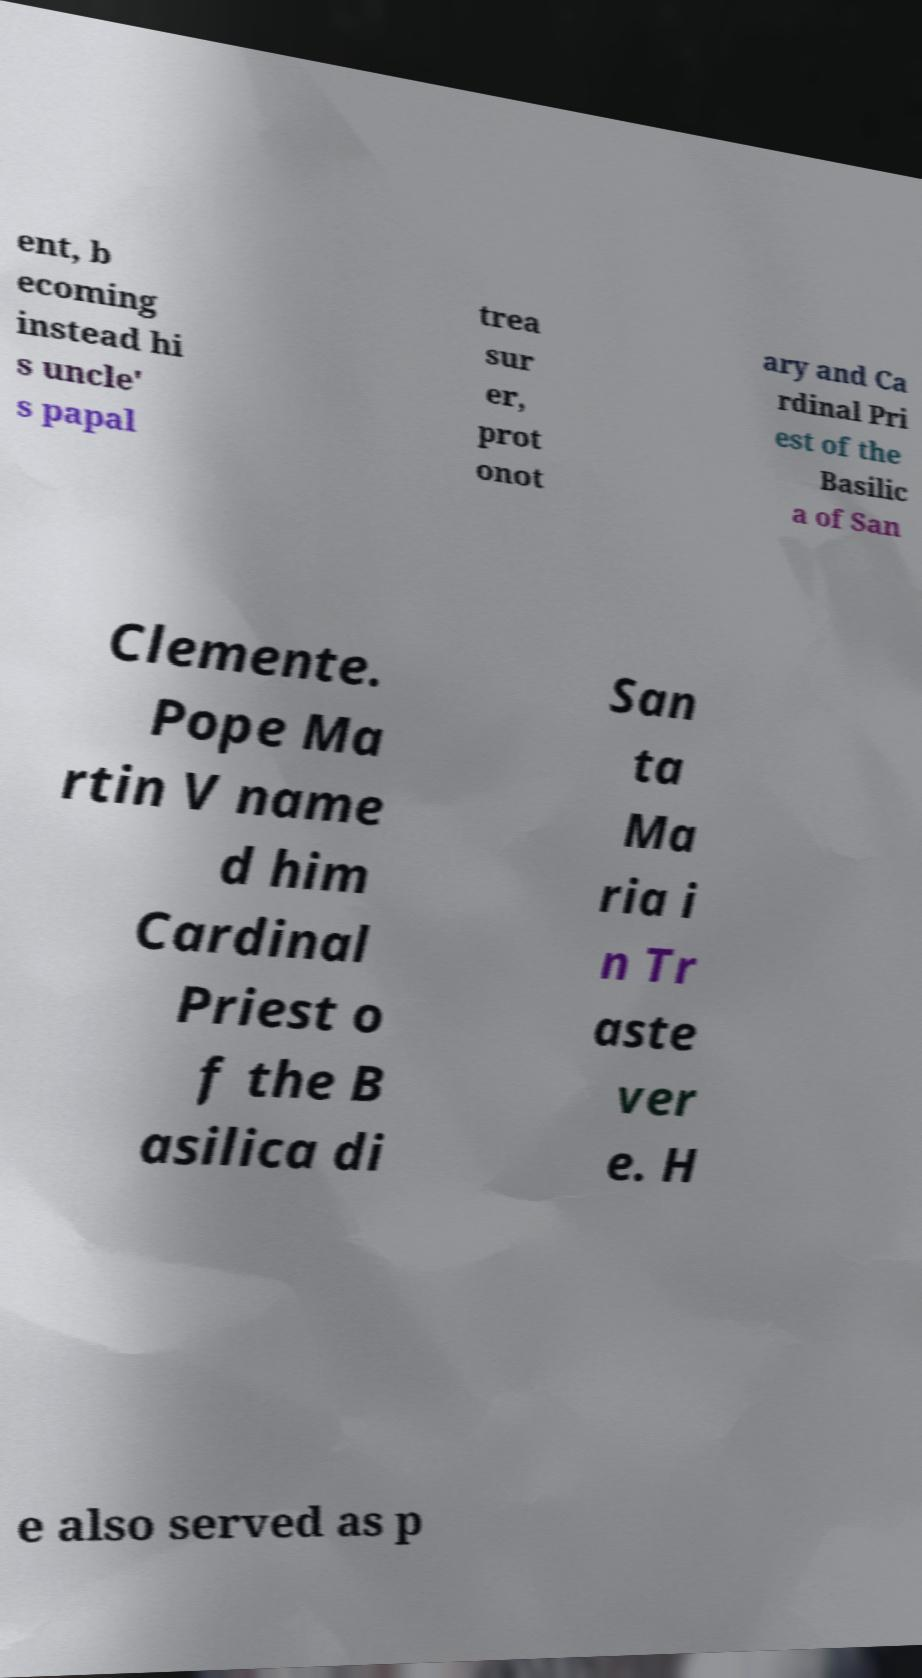There's text embedded in this image that I need extracted. Can you transcribe it verbatim? ent, b ecoming instead hi s uncle' s papal trea sur er, prot onot ary and Ca rdinal Pri est of the Basilic a of San Clemente. Pope Ma rtin V name d him Cardinal Priest o f the B asilica di San ta Ma ria i n Tr aste ver e. H e also served as p 